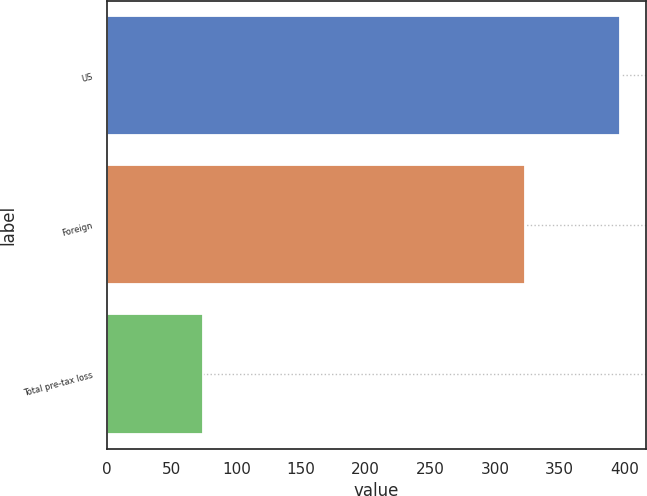Convert chart to OTSL. <chart><loc_0><loc_0><loc_500><loc_500><bar_chart><fcel>US<fcel>Foreign<fcel>Total pre-tax loss<nl><fcel>397<fcel>323<fcel>74<nl></chart> 